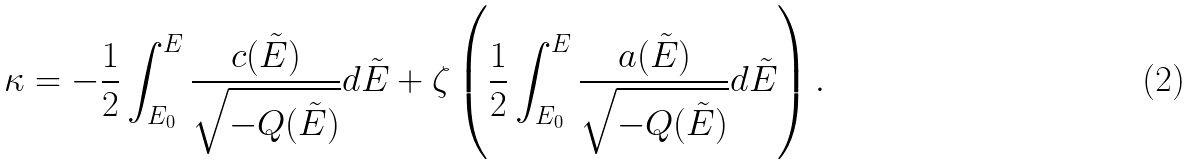Convert formula to latex. <formula><loc_0><loc_0><loc_500><loc_500>& \kappa = - \frac { 1 } { 2 } \int _ { E _ { 0 } } ^ { E } \frac { c ( \tilde { E } ) } { \sqrt { - Q ( \tilde { E } ) } } d \tilde { E } + \zeta \left ( \frac { 1 } { 2 } \int _ { E _ { 0 } } ^ { E } \frac { a ( \tilde { E } ) } { \sqrt { - Q ( \tilde { E } ) } } d \tilde { E } \right ) .</formula> 